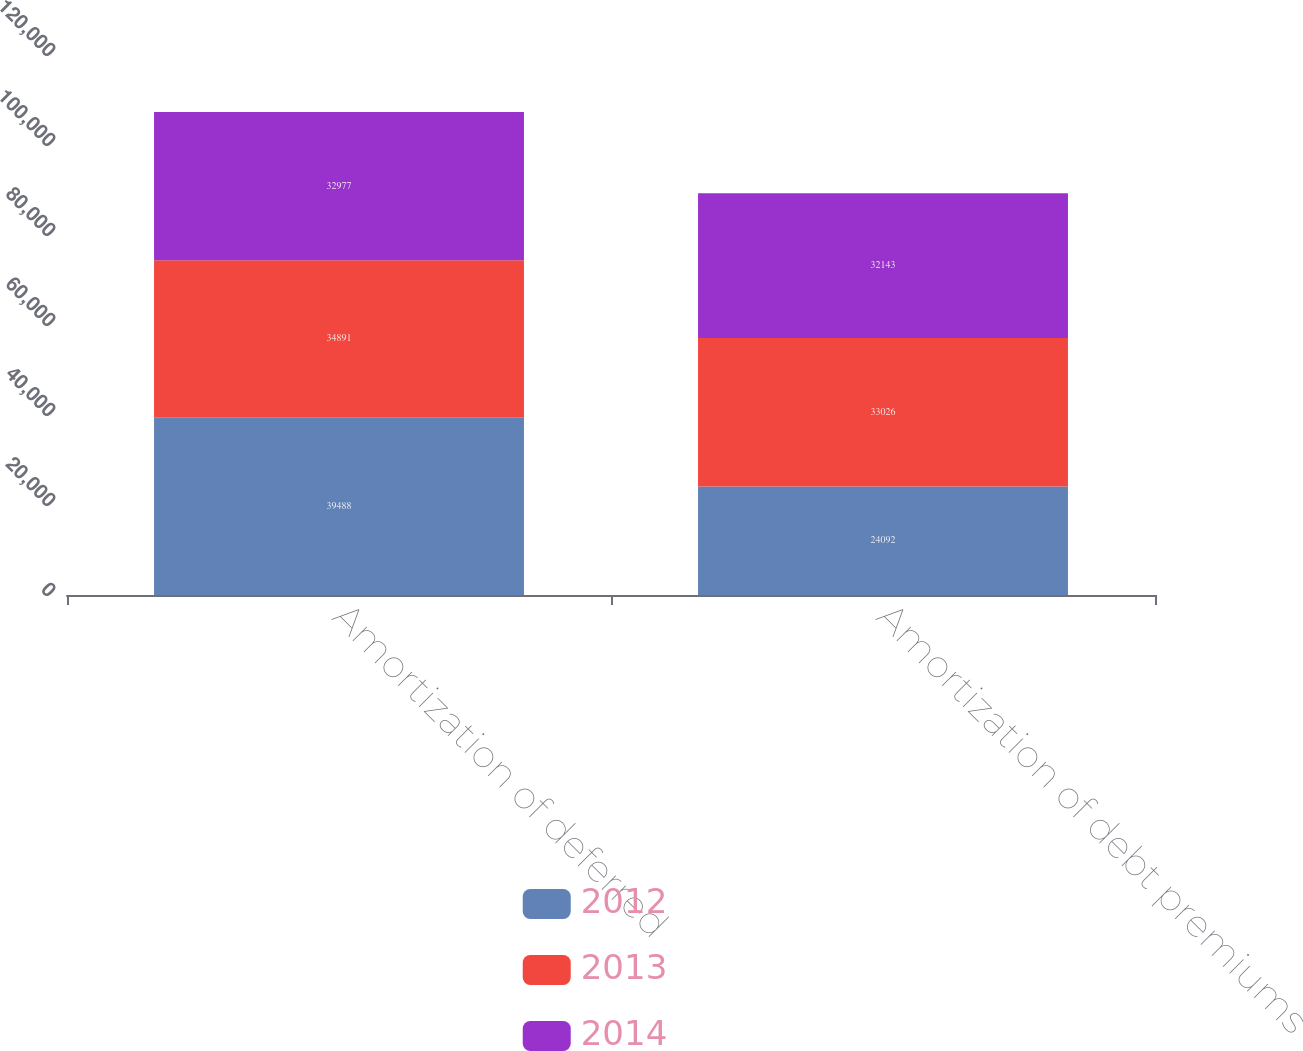<chart> <loc_0><loc_0><loc_500><loc_500><stacked_bar_chart><ecel><fcel>Amortization of deferred<fcel>Amortization of debt premiums<nl><fcel>2012<fcel>39488<fcel>24092<nl><fcel>2013<fcel>34891<fcel>33026<nl><fcel>2014<fcel>32977<fcel>32143<nl></chart> 